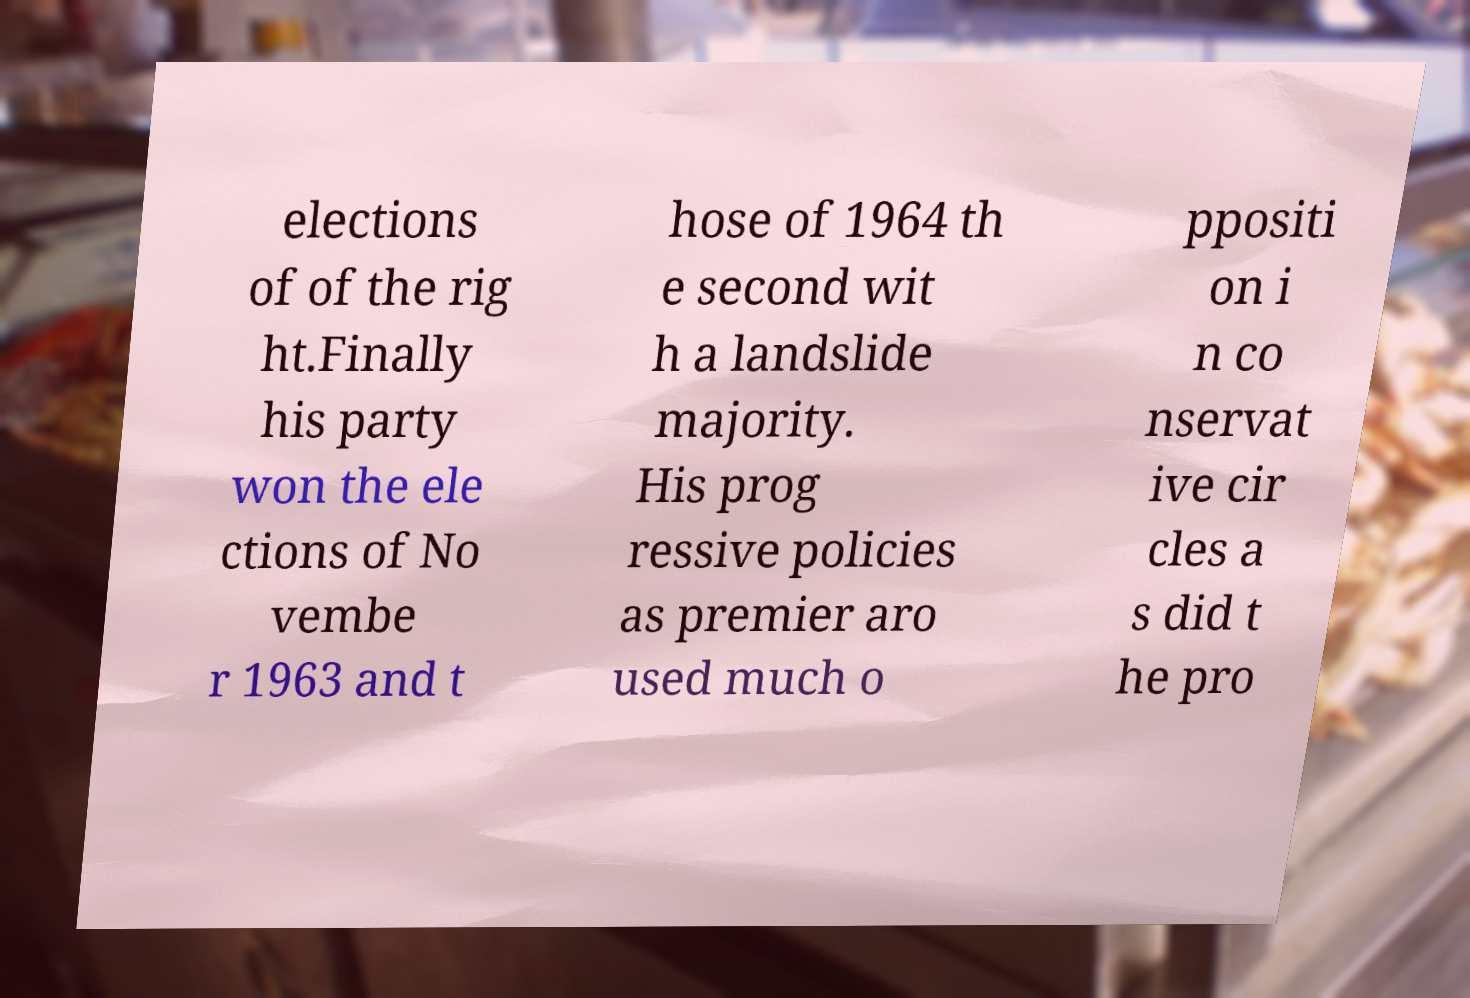Please identify and transcribe the text found in this image. elections of of the rig ht.Finally his party won the ele ctions of No vembe r 1963 and t hose of 1964 th e second wit h a landslide majority. His prog ressive policies as premier aro used much o ppositi on i n co nservat ive cir cles a s did t he pro 